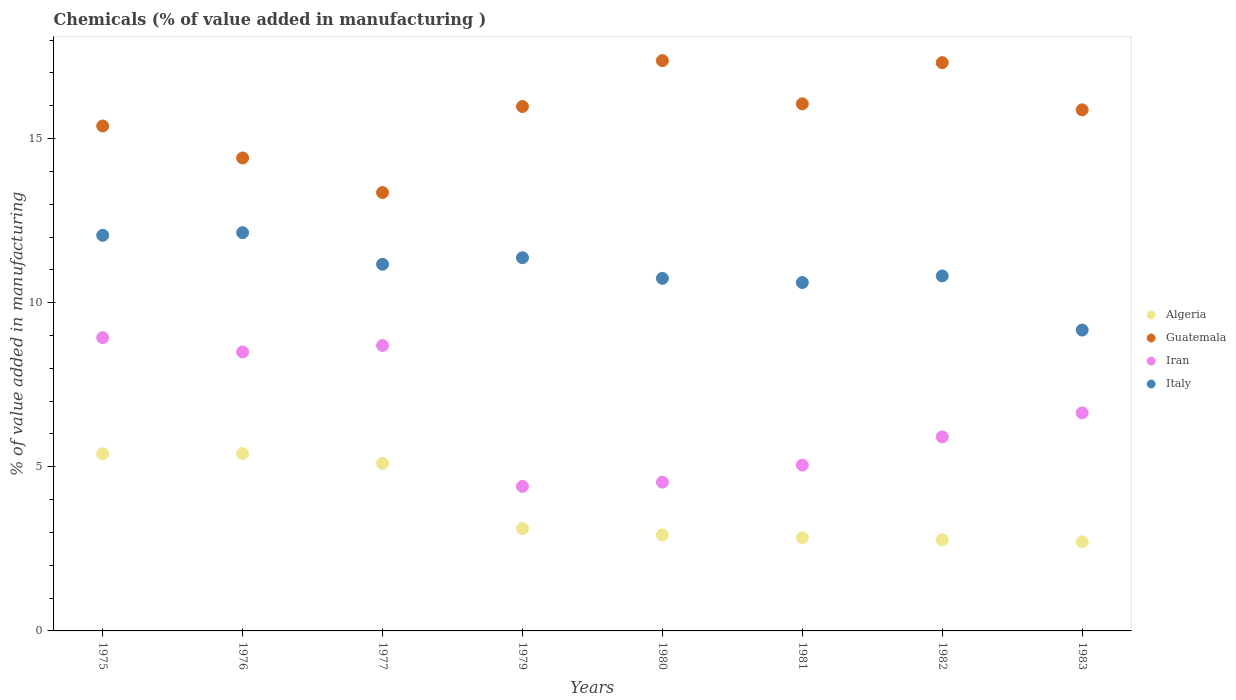How many different coloured dotlines are there?
Give a very brief answer. 4. What is the value added in manufacturing chemicals in Italy in 1976?
Ensure brevity in your answer.  12.13. Across all years, what is the maximum value added in manufacturing chemicals in Algeria?
Provide a succinct answer. 5.4. Across all years, what is the minimum value added in manufacturing chemicals in Guatemala?
Offer a very short reply. 13.36. In which year was the value added in manufacturing chemicals in Iran maximum?
Provide a short and direct response. 1975. In which year was the value added in manufacturing chemicals in Guatemala minimum?
Give a very brief answer. 1977. What is the total value added in manufacturing chemicals in Iran in the graph?
Give a very brief answer. 52.67. What is the difference between the value added in manufacturing chemicals in Iran in 1982 and that in 1983?
Your response must be concise. -0.73. What is the difference between the value added in manufacturing chemicals in Iran in 1975 and the value added in manufacturing chemicals in Guatemala in 1981?
Your answer should be compact. -7.12. What is the average value added in manufacturing chemicals in Iran per year?
Keep it short and to the point. 6.58. In the year 1981, what is the difference between the value added in manufacturing chemicals in Guatemala and value added in manufacturing chemicals in Italy?
Your answer should be compact. 5.44. In how many years, is the value added in manufacturing chemicals in Italy greater than 5 %?
Your response must be concise. 8. What is the ratio of the value added in manufacturing chemicals in Algeria in 1975 to that in 1982?
Provide a short and direct response. 1.94. Is the difference between the value added in manufacturing chemicals in Guatemala in 1977 and 1982 greater than the difference between the value added in manufacturing chemicals in Italy in 1977 and 1982?
Your answer should be very brief. No. What is the difference between the highest and the second highest value added in manufacturing chemicals in Iran?
Give a very brief answer. 0.24. What is the difference between the highest and the lowest value added in manufacturing chemicals in Algeria?
Keep it short and to the point. 2.69. In how many years, is the value added in manufacturing chemicals in Italy greater than the average value added in manufacturing chemicals in Italy taken over all years?
Your answer should be very brief. 4. Is it the case that in every year, the sum of the value added in manufacturing chemicals in Algeria and value added in manufacturing chemicals in Iran  is greater than the sum of value added in manufacturing chemicals in Guatemala and value added in manufacturing chemicals in Italy?
Offer a terse response. No. Does the value added in manufacturing chemicals in Algeria monotonically increase over the years?
Your answer should be very brief. No. Is the value added in manufacturing chemicals in Guatemala strictly less than the value added in manufacturing chemicals in Iran over the years?
Keep it short and to the point. No. How many dotlines are there?
Your response must be concise. 4. How many years are there in the graph?
Your response must be concise. 8. What is the difference between two consecutive major ticks on the Y-axis?
Your response must be concise. 5. Are the values on the major ticks of Y-axis written in scientific E-notation?
Your answer should be compact. No. Does the graph contain grids?
Keep it short and to the point. No. Where does the legend appear in the graph?
Give a very brief answer. Center right. How many legend labels are there?
Give a very brief answer. 4. How are the legend labels stacked?
Ensure brevity in your answer.  Vertical. What is the title of the graph?
Provide a short and direct response. Chemicals (% of value added in manufacturing ). Does "Micronesia" appear as one of the legend labels in the graph?
Offer a very short reply. No. What is the label or title of the Y-axis?
Your answer should be compact. % of value added in manufacturing. What is the % of value added in manufacturing in Algeria in 1975?
Keep it short and to the point. 5.4. What is the % of value added in manufacturing in Guatemala in 1975?
Your answer should be compact. 15.38. What is the % of value added in manufacturing of Iran in 1975?
Give a very brief answer. 8.94. What is the % of value added in manufacturing in Italy in 1975?
Offer a very short reply. 12.05. What is the % of value added in manufacturing in Algeria in 1976?
Make the answer very short. 5.4. What is the % of value added in manufacturing in Guatemala in 1976?
Keep it short and to the point. 14.41. What is the % of value added in manufacturing in Iran in 1976?
Provide a short and direct response. 8.5. What is the % of value added in manufacturing of Italy in 1976?
Your response must be concise. 12.13. What is the % of value added in manufacturing in Algeria in 1977?
Your response must be concise. 5.1. What is the % of value added in manufacturing of Guatemala in 1977?
Keep it short and to the point. 13.36. What is the % of value added in manufacturing in Iran in 1977?
Provide a succinct answer. 8.7. What is the % of value added in manufacturing of Italy in 1977?
Ensure brevity in your answer.  11.17. What is the % of value added in manufacturing of Algeria in 1979?
Offer a very short reply. 3.12. What is the % of value added in manufacturing of Guatemala in 1979?
Give a very brief answer. 15.98. What is the % of value added in manufacturing of Iran in 1979?
Offer a very short reply. 4.4. What is the % of value added in manufacturing in Italy in 1979?
Ensure brevity in your answer.  11.37. What is the % of value added in manufacturing in Algeria in 1980?
Provide a short and direct response. 2.93. What is the % of value added in manufacturing of Guatemala in 1980?
Your answer should be very brief. 17.37. What is the % of value added in manufacturing of Iran in 1980?
Make the answer very short. 4.53. What is the % of value added in manufacturing in Italy in 1980?
Offer a terse response. 10.74. What is the % of value added in manufacturing of Algeria in 1981?
Your response must be concise. 2.84. What is the % of value added in manufacturing in Guatemala in 1981?
Your answer should be compact. 16.06. What is the % of value added in manufacturing in Iran in 1981?
Give a very brief answer. 5.05. What is the % of value added in manufacturing in Italy in 1981?
Give a very brief answer. 10.61. What is the % of value added in manufacturing of Algeria in 1982?
Your response must be concise. 2.78. What is the % of value added in manufacturing in Guatemala in 1982?
Offer a terse response. 17.31. What is the % of value added in manufacturing of Iran in 1982?
Your response must be concise. 5.91. What is the % of value added in manufacturing of Italy in 1982?
Your answer should be compact. 10.82. What is the % of value added in manufacturing of Algeria in 1983?
Offer a very short reply. 2.71. What is the % of value added in manufacturing of Guatemala in 1983?
Provide a succinct answer. 15.88. What is the % of value added in manufacturing in Iran in 1983?
Provide a short and direct response. 6.64. What is the % of value added in manufacturing in Italy in 1983?
Provide a succinct answer. 9.17. Across all years, what is the maximum % of value added in manufacturing in Algeria?
Make the answer very short. 5.4. Across all years, what is the maximum % of value added in manufacturing of Guatemala?
Make the answer very short. 17.37. Across all years, what is the maximum % of value added in manufacturing of Iran?
Offer a terse response. 8.94. Across all years, what is the maximum % of value added in manufacturing in Italy?
Your response must be concise. 12.13. Across all years, what is the minimum % of value added in manufacturing of Algeria?
Provide a succinct answer. 2.71. Across all years, what is the minimum % of value added in manufacturing of Guatemala?
Your answer should be very brief. 13.36. Across all years, what is the minimum % of value added in manufacturing in Iran?
Provide a short and direct response. 4.4. Across all years, what is the minimum % of value added in manufacturing in Italy?
Make the answer very short. 9.17. What is the total % of value added in manufacturing in Algeria in the graph?
Give a very brief answer. 30.27. What is the total % of value added in manufacturing of Guatemala in the graph?
Make the answer very short. 125.74. What is the total % of value added in manufacturing of Iran in the graph?
Your answer should be compact. 52.67. What is the total % of value added in manufacturing of Italy in the graph?
Provide a succinct answer. 88.06. What is the difference between the % of value added in manufacturing of Algeria in 1975 and that in 1976?
Ensure brevity in your answer.  -0.01. What is the difference between the % of value added in manufacturing of Guatemala in 1975 and that in 1976?
Offer a very short reply. 0.97. What is the difference between the % of value added in manufacturing in Iran in 1975 and that in 1976?
Your answer should be very brief. 0.44. What is the difference between the % of value added in manufacturing of Italy in 1975 and that in 1976?
Provide a short and direct response. -0.08. What is the difference between the % of value added in manufacturing of Algeria in 1975 and that in 1977?
Your response must be concise. 0.29. What is the difference between the % of value added in manufacturing of Guatemala in 1975 and that in 1977?
Offer a very short reply. 2.03. What is the difference between the % of value added in manufacturing of Iran in 1975 and that in 1977?
Provide a succinct answer. 0.24. What is the difference between the % of value added in manufacturing of Italy in 1975 and that in 1977?
Your response must be concise. 0.88. What is the difference between the % of value added in manufacturing in Algeria in 1975 and that in 1979?
Provide a short and direct response. 2.28. What is the difference between the % of value added in manufacturing in Guatemala in 1975 and that in 1979?
Your answer should be compact. -0.59. What is the difference between the % of value added in manufacturing in Iran in 1975 and that in 1979?
Give a very brief answer. 4.53. What is the difference between the % of value added in manufacturing of Italy in 1975 and that in 1979?
Make the answer very short. 0.68. What is the difference between the % of value added in manufacturing of Algeria in 1975 and that in 1980?
Your answer should be very brief. 2.47. What is the difference between the % of value added in manufacturing of Guatemala in 1975 and that in 1980?
Offer a very short reply. -1.99. What is the difference between the % of value added in manufacturing of Iran in 1975 and that in 1980?
Keep it short and to the point. 4.4. What is the difference between the % of value added in manufacturing in Italy in 1975 and that in 1980?
Your answer should be very brief. 1.31. What is the difference between the % of value added in manufacturing in Algeria in 1975 and that in 1981?
Make the answer very short. 2.56. What is the difference between the % of value added in manufacturing of Guatemala in 1975 and that in 1981?
Provide a succinct answer. -0.68. What is the difference between the % of value added in manufacturing in Iran in 1975 and that in 1981?
Give a very brief answer. 3.88. What is the difference between the % of value added in manufacturing of Italy in 1975 and that in 1981?
Your answer should be compact. 1.44. What is the difference between the % of value added in manufacturing in Algeria in 1975 and that in 1982?
Keep it short and to the point. 2.62. What is the difference between the % of value added in manufacturing in Guatemala in 1975 and that in 1982?
Your response must be concise. -1.93. What is the difference between the % of value added in manufacturing in Iran in 1975 and that in 1982?
Provide a short and direct response. 3.03. What is the difference between the % of value added in manufacturing of Italy in 1975 and that in 1982?
Keep it short and to the point. 1.24. What is the difference between the % of value added in manufacturing in Algeria in 1975 and that in 1983?
Give a very brief answer. 2.68. What is the difference between the % of value added in manufacturing of Guatemala in 1975 and that in 1983?
Ensure brevity in your answer.  -0.49. What is the difference between the % of value added in manufacturing in Iran in 1975 and that in 1983?
Your answer should be compact. 2.29. What is the difference between the % of value added in manufacturing in Italy in 1975 and that in 1983?
Your answer should be very brief. 2.89. What is the difference between the % of value added in manufacturing of Algeria in 1976 and that in 1977?
Offer a very short reply. 0.3. What is the difference between the % of value added in manufacturing in Guatemala in 1976 and that in 1977?
Make the answer very short. 1.05. What is the difference between the % of value added in manufacturing of Iran in 1976 and that in 1977?
Provide a short and direct response. -0.2. What is the difference between the % of value added in manufacturing in Italy in 1976 and that in 1977?
Make the answer very short. 0.96. What is the difference between the % of value added in manufacturing of Algeria in 1976 and that in 1979?
Offer a terse response. 2.28. What is the difference between the % of value added in manufacturing of Guatemala in 1976 and that in 1979?
Offer a very short reply. -1.57. What is the difference between the % of value added in manufacturing of Iran in 1976 and that in 1979?
Provide a short and direct response. 4.1. What is the difference between the % of value added in manufacturing of Italy in 1976 and that in 1979?
Give a very brief answer. 0.76. What is the difference between the % of value added in manufacturing of Algeria in 1976 and that in 1980?
Make the answer very short. 2.48. What is the difference between the % of value added in manufacturing of Guatemala in 1976 and that in 1980?
Provide a succinct answer. -2.97. What is the difference between the % of value added in manufacturing of Iran in 1976 and that in 1980?
Your answer should be very brief. 3.97. What is the difference between the % of value added in manufacturing in Italy in 1976 and that in 1980?
Make the answer very short. 1.39. What is the difference between the % of value added in manufacturing of Algeria in 1976 and that in 1981?
Your answer should be very brief. 2.56. What is the difference between the % of value added in manufacturing in Guatemala in 1976 and that in 1981?
Make the answer very short. -1.65. What is the difference between the % of value added in manufacturing of Iran in 1976 and that in 1981?
Give a very brief answer. 3.45. What is the difference between the % of value added in manufacturing of Italy in 1976 and that in 1981?
Provide a succinct answer. 1.52. What is the difference between the % of value added in manufacturing in Algeria in 1976 and that in 1982?
Make the answer very short. 2.62. What is the difference between the % of value added in manufacturing in Guatemala in 1976 and that in 1982?
Your answer should be compact. -2.9. What is the difference between the % of value added in manufacturing in Iran in 1976 and that in 1982?
Keep it short and to the point. 2.59. What is the difference between the % of value added in manufacturing of Italy in 1976 and that in 1982?
Your answer should be very brief. 1.32. What is the difference between the % of value added in manufacturing of Algeria in 1976 and that in 1983?
Your response must be concise. 2.69. What is the difference between the % of value added in manufacturing of Guatemala in 1976 and that in 1983?
Make the answer very short. -1.47. What is the difference between the % of value added in manufacturing in Iran in 1976 and that in 1983?
Provide a succinct answer. 1.86. What is the difference between the % of value added in manufacturing of Italy in 1976 and that in 1983?
Provide a short and direct response. 2.97. What is the difference between the % of value added in manufacturing of Algeria in 1977 and that in 1979?
Provide a short and direct response. 1.98. What is the difference between the % of value added in manufacturing in Guatemala in 1977 and that in 1979?
Your answer should be compact. -2.62. What is the difference between the % of value added in manufacturing in Iran in 1977 and that in 1979?
Give a very brief answer. 4.29. What is the difference between the % of value added in manufacturing in Italy in 1977 and that in 1979?
Your answer should be compact. -0.2. What is the difference between the % of value added in manufacturing in Algeria in 1977 and that in 1980?
Offer a very short reply. 2.18. What is the difference between the % of value added in manufacturing in Guatemala in 1977 and that in 1980?
Your response must be concise. -4.02. What is the difference between the % of value added in manufacturing of Iran in 1977 and that in 1980?
Your answer should be very brief. 4.16. What is the difference between the % of value added in manufacturing in Italy in 1977 and that in 1980?
Make the answer very short. 0.43. What is the difference between the % of value added in manufacturing in Algeria in 1977 and that in 1981?
Offer a terse response. 2.26. What is the difference between the % of value added in manufacturing in Guatemala in 1977 and that in 1981?
Keep it short and to the point. -2.7. What is the difference between the % of value added in manufacturing in Iran in 1977 and that in 1981?
Provide a short and direct response. 3.64. What is the difference between the % of value added in manufacturing of Italy in 1977 and that in 1981?
Your answer should be compact. 0.56. What is the difference between the % of value added in manufacturing in Algeria in 1977 and that in 1982?
Your answer should be compact. 2.32. What is the difference between the % of value added in manufacturing of Guatemala in 1977 and that in 1982?
Offer a very short reply. -3.96. What is the difference between the % of value added in manufacturing of Iran in 1977 and that in 1982?
Provide a succinct answer. 2.78. What is the difference between the % of value added in manufacturing of Italy in 1977 and that in 1982?
Offer a terse response. 0.36. What is the difference between the % of value added in manufacturing in Algeria in 1977 and that in 1983?
Make the answer very short. 2.39. What is the difference between the % of value added in manufacturing of Guatemala in 1977 and that in 1983?
Make the answer very short. -2.52. What is the difference between the % of value added in manufacturing of Iran in 1977 and that in 1983?
Your answer should be compact. 2.05. What is the difference between the % of value added in manufacturing in Italy in 1977 and that in 1983?
Offer a terse response. 2. What is the difference between the % of value added in manufacturing in Algeria in 1979 and that in 1980?
Offer a terse response. 0.19. What is the difference between the % of value added in manufacturing in Guatemala in 1979 and that in 1980?
Offer a terse response. -1.4. What is the difference between the % of value added in manufacturing in Iran in 1979 and that in 1980?
Provide a short and direct response. -0.13. What is the difference between the % of value added in manufacturing of Italy in 1979 and that in 1980?
Make the answer very short. 0.63. What is the difference between the % of value added in manufacturing of Algeria in 1979 and that in 1981?
Provide a short and direct response. 0.28. What is the difference between the % of value added in manufacturing in Guatemala in 1979 and that in 1981?
Offer a very short reply. -0.08. What is the difference between the % of value added in manufacturing in Iran in 1979 and that in 1981?
Make the answer very short. -0.65. What is the difference between the % of value added in manufacturing of Italy in 1979 and that in 1981?
Ensure brevity in your answer.  0.76. What is the difference between the % of value added in manufacturing of Algeria in 1979 and that in 1982?
Keep it short and to the point. 0.34. What is the difference between the % of value added in manufacturing in Guatemala in 1979 and that in 1982?
Offer a very short reply. -1.34. What is the difference between the % of value added in manufacturing in Iran in 1979 and that in 1982?
Your response must be concise. -1.51. What is the difference between the % of value added in manufacturing of Italy in 1979 and that in 1982?
Your answer should be compact. 0.55. What is the difference between the % of value added in manufacturing in Algeria in 1979 and that in 1983?
Keep it short and to the point. 0.41. What is the difference between the % of value added in manufacturing in Guatemala in 1979 and that in 1983?
Provide a short and direct response. 0.1. What is the difference between the % of value added in manufacturing of Iran in 1979 and that in 1983?
Keep it short and to the point. -2.24. What is the difference between the % of value added in manufacturing in Italy in 1979 and that in 1983?
Keep it short and to the point. 2.2. What is the difference between the % of value added in manufacturing in Algeria in 1980 and that in 1981?
Provide a succinct answer. 0.09. What is the difference between the % of value added in manufacturing in Guatemala in 1980 and that in 1981?
Provide a short and direct response. 1.32. What is the difference between the % of value added in manufacturing of Iran in 1980 and that in 1981?
Ensure brevity in your answer.  -0.52. What is the difference between the % of value added in manufacturing in Italy in 1980 and that in 1981?
Your response must be concise. 0.13. What is the difference between the % of value added in manufacturing of Algeria in 1980 and that in 1982?
Give a very brief answer. 0.15. What is the difference between the % of value added in manufacturing in Guatemala in 1980 and that in 1982?
Your answer should be very brief. 0.06. What is the difference between the % of value added in manufacturing of Iran in 1980 and that in 1982?
Make the answer very short. -1.38. What is the difference between the % of value added in manufacturing of Italy in 1980 and that in 1982?
Offer a terse response. -0.07. What is the difference between the % of value added in manufacturing in Algeria in 1980 and that in 1983?
Offer a very short reply. 0.21. What is the difference between the % of value added in manufacturing of Guatemala in 1980 and that in 1983?
Your answer should be compact. 1.5. What is the difference between the % of value added in manufacturing in Iran in 1980 and that in 1983?
Your answer should be very brief. -2.11. What is the difference between the % of value added in manufacturing in Italy in 1980 and that in 1983?
Give a very brief answer. 1.57. What is the difference between the % of value added in manufacturing of Algeria in 1981 and that in 1982?
Provide a succinct answer. 0.06. What is the difference between the % of value added in manufacturing of Guatemala in 1981 and that in 1982?
Offer a terse response. -1.25. What is the difference between the % of value added in manufacturing of Iran in 1981 and that in 1982?
Keep it short and to the point. -0.86. What is the difference between the % of value added in manufacturing in Italy in 1981 and that in 1982?
Offer a very short reply. -0.2. What is the difference between the % of value added in manufacturing of Algeria in 1981 and that in 1983?
Give a very brief answer. 0.13. What is the difference between the % of value added in manufacturing of Guatemala in 1981 and that in 1983?
Give a very brief answer. 0.18. What is the difference between the % of value added in manufacturing of Iran in 1981 and that in 1983?
Provide a short and direct response. -1.59. What is the difference between the % of value added in manufacturing in Italy in 1981 and that in 1983?
Keep it short and to the point. 1.45. What is the difference between the % of value added in manufacturing of Algeria in 1982 and that in 1983?
Provide a short and direct response. 0.07. What is the difference between the % of value added in manufacturing in Guatemala in 1982 and that in 1983?
Keep it short and to the point. 1.44. What is the difference between the % of value added in manufacturing in Iran in 1982 and that in 1983?
Offer a terse response. -0.73. What is the difference between the % of value added in manufacturing of Italy in 1982 and that in 1983?
Your response must be concise. 1.65. What is the difference between the % of value added in manufacturing of Algeria in 1975 and the % of value added in manufacturing of Guatemala in 1976?
Offer a terse response. -9.01. What is the difference between the % of value added in manufacturing of Algeria in 1975 and the % of value added in manufacturing of Iran in 1976?
Provide a succinct answer. -3.1. What is the difference between the % of value added in manufacturing in Algeria in 1975 and the % of value added in manufacturing in Italy in 1976?
Keep it short and to the point. -6.74. What is the difference between the % of value added in manufacturing in Guatemala in 1975 and the % of value added in manufacturing in Iran in 1976?
Your answer should be very brief. 6.88. What is the difference between the % of value added in manufacturing of Guatemala in 1975 and the % of value added in manufacturing of Italy in 1976?
Provide a short and direct response. 3.25. What is the difference between the % of value added in manufacturing of Iran in 1975 and the % of value added in manufacturing of Italy in 1976?
Your answer should be compact. -3.2. What is the difference between the % of value added in manufacturing of Algeria in 1975 and the % of value added in manufacturing of Guatemala in 1977?
Offer a terse response. -7.96. What is the difference between the % of value added in manufacturing in Algeria in 1975 and the % of value added in manufacturing in Iran in 1977?
Give a very brief answer. -3.3. What is the difference between the % of value added in manufacturing of Algeria in 1975 and the % of value added in manufacturing of Italy in 1977?
Your answer should be very brief. -5.78. What is the difference between the % of value added in manufacturing in Guatemala in 1975 and the % of value added in manufacturing in Iran in 1977?
Provide a succinct answer. 6.69. What is the difference between the % of value added in manufacturing of Guatemala in 1975 and the % of value added in manufacturing of Italy in 1977?
Provide a short and direct response. 4.21. What is the difference between the % of value added in manufacturing in Iran in 1975 and the % of value added in manufacturing in Italy in 1977?
Your response must be concise. -2.23. What is the difference between the % of value added in manufacturing of Algeria in 1975 and the % of value added in manufacturing of Guatemala in 1979?
Give a very brief answer. -10.58. What is the difference between the % of value added in manufacturing of Algeria in 1975 and the % of value added in manufacturing of Italy in 1979?
Provide a succinct answer. -5.97. What is the difference between the % of value added in manufacturing of Guatemala in 1975 and the % of value added in manufacturing of Iran in 1979?
Give a very brief answer. 10.98. What is the difference between the % of value added in manufacturing of Guatemala in 1975 and the % of value added in manufacturing of Italy in 1979?
Your response must be concise. 4.01. What is the difference between the % of value added in manufacturing of Iran in 1975 and the % of value added in manufacturing of Italy in 1979?
Make the answer very short. -2.43. What is the difference between the % of value added in manufacturing of Algeria in 1975 and the % of value added in manufacturing of Guatemala in 1980?
Give a very brief answer. -11.98. What is the difference between the % of value added in manufacturing in Algeria in 1975 and the % of value added in manufacturing in Iran in 1980?
Give a very brief answer. 0.86. What is the difference between the % of value added in manufacturing in Algeria in 1975 and the % of value added in manufacturing in Italy in 1980?
Make the answer very short. -5.35. What is the difference between the % of value added in manufacturing of Guatemala in 1975 and the % of value added in manufacturing of Iran in 1980?
Offer a very short reply. 10.85. What is the difference between the % of value added in manufacturing in Guatemala in 1975 and the % of value added in manufacturing in Italy in 1980?
Make the answer very short. 4.64. What is the difference between the % of value added in manufacturing of Iran in 1975 and the % of value added in manufacturing of Italy in 1980?
Ensure brevity in your answer.  -1.8. What is the difference between the % of value added in manufacturing of Algeria in 1975 and the % of value added in manufacturing of Guatemala in 1981?
Your answer should be compact. -10.66. What is the difference between the % of value added in manufacturing in Algeria in 1975 and the % of value added in manufacturing in Iran in 1981?
Keep it short and to the point. 0.34. What is the difference between the % of value added in manufacturing of Algeria in 1975 and the % of value added in manufacturing of Italy in 1981?
Your response must be concise. -5.22. What is the difference between the % of value added in manufacturing in Guatemala in 1975 and the % of value added in manufacturing in Iran in 1981?
Your response must be concise. 10.33. What is the difference between the % of value added in manufacturing in Guatemala in 1975 and the % of value added in manufacturing in Italy in 1981?
Your answer should be very brief. 4.77. What is the difference between the % of value added in manufacturing in Iran in 1975 and the % of value added in manufacturing in Italy in 1981?
Your response must be concise. -1.68. What is the difference between the % of value added in manufacturing of Algeria in 1975 and the % of value added in manufacturing of Guatemala in 1982?
Your response must be concise. -11.92. What is the difference between the % of value added in manufacturing of Algeria in 1975 and the % of value added in manufacturing of Iran in 1982?
Ensure brevity in your answer.  -0.52. What is the difference between the % of value added in manufacturing in Algeria in 1975 and the % of value added in manufacturing in Italy in 1982?
Give a very brief answer. -5.42. What is the difference between the % of value added in manufacturing in Guatemala in 1975 and the % of value added in manufacturing in Iran in 1982?
Your response must be concise. 9.47. What is the difference between the % of value added in manufacturing in Guatemala in 1975 and the % of value added in manufacturing in Italy in 1982?
Make the answer very short. 4.57. What is the difference between the % of value added in manufacturing of Iran in 1975 and the % of value added in manufacturing of Italy in 1982?
Keep it short and to the point. -1.88. What is the difference between the % of value added in manufacturing of Algeria in 1975 and the % of value added in manufacturing of Guatemala in 1983?
Give a very brief answer. -10.48. What is the difference between the % of value added in manufacturing of Algeria in 1975 and the % of value added in manufacturing of Iran in 1983?
Provide a succinct answer. -1.25. What is the difference between the % of value added in manufacturing in Algeria in 1975 and the % of value added in manufacturing in Italy in 1983?
Keep it short and to the point. -3.77. What is the difference between the % of value added in manufacturing of Guatemala in 1975 and the % of value added in manufacturing of Iran in 1983?
Your answer should be very brief. 8.74. What is the difference between the % of value added in manufacturing of Guatemala in 1975 and the % of value added in manufacturing of Italy in 1983?
Your answer should be compact. 6.22. What is the difference between the % of value added in manufacturing of Iran in 1975 and the % of value added in manufacturing of Italy in 1983?
Provide a succinct answer. -0.23. What is the difference between the % of value added in manufacturing in Algeria in 1976 and the % of value added in manufacturing in Guatemala in 1977?
Provide a short and direct response. -7.95. What is the difference between the % of value added in manufacturing of Algeria in 1976 and the % of value added in manufacturing of Iran in 1977?
Your answer should be compact. -3.29. What is the difference between the % of value added in manufacturing of Algeria in 1976 and the % of value added in manufacturing of Italy in 1977?
Give a very brief answer. -5.77. What is the difference between the % of value added in manufacturing of Guatemala in 1976 and the % of value added in manufacturing of Iran in 1977?
Your answer should be compact. 5.71. What is the difference between the % of value added in manufacturing in Guatemala in 1976 and the % of value added in manufacturing in Italy in 1977?
Ensure brevity in your answer.  3.24. What is the difference between the % of value added in manufacturing of Iran in 1976 and the % of value added in manufacturing of Italy in 1977?
Ensure brevity in your answer.  -2.67. What is the difference between the % of value added in manufacturing in Algeria in 1976 and the % of value added in manufacturing in Guatemala in 1979?
Give a very brief answer. -10.57. What is the difference between the % of value added in manufacturing in Algeria in 1976 and the % of value added in manufacturing in Italy in 1979?
Provide a succinct answer. -5.97. What is the difference between the % of value added in manufacturing in Guatemala in 1976 and the % of value added in manufacturing in Iran in 1979?
Offer a very short reply. 10.01. What is the difference between the % of value added in manufacturing of Guatemala in 1976 and the % of value added in manufacturing of Italy in 1979?
Keep it short and to the point. 3.04. What is the difference between the % of value added in manufacturing of Iran in 1976 and the % of value added in manufacturing of Italy in 1979?
Offer a very short reply. -2.87. What is the difference between the % of value added in manufacturing of Algeria in 1976 and the % of value added in manufacturing of Guatemala in 1980?
Keep it short and to the point. -11.97. What is the difference between the % of value added in manufacturing in Algeria in 1976 and the % of value added in manufacturing in Iran in 1980?
Offer a terse response. 0.87. What is the difference between the % of value added in manufacturing in Algeria in 1976 and the % of value added in manufacturing in Italy in 1980?
Provide a succinct answer. -5.34. What is the difference between the % of value added in manufacturing in Guatemala in 1976 and the % of value added in manufacturing in Iran in 1980?
Provide a succinct answer. 9.88. What is the difference between the % of value added in manufacturing of Guatemala in 1976 and the % of value added in manufacturing of Italy in 1980?
Provide a succinct answer. 3.67. What is the difference between the % of value added in manufacturing in Iran in 1976 and the % of value added in manufacturing in Italy in 1980?
Offer a terse response. -2.24. What is the difference between the % of value added in manufacturing in Algeria in 1976 and the % of value added in manufacturing in Guatemala in 1981?
Make the answer very short. -10.66. What is the difference between the % of value added in manufacturing in Algeria in 1976 and the % of value added in manufacturing in Iran in 1981?
Offer a terse response. 0.35. What is the difference between the % of value added in manufacturing of Algeria in 1976 and the % of value added in manufacturing of Italy in 1981?
Offer a very short reply. -5.21. What is the difference between the % of value added in manufacturing in Guatemala in 1976 and the % of value added in manufacturing in Iran in 1981?
Your answer should be compact. 9.36. What is the difference between the % of value added in manufacturing in Guatemala in 1976 and the % of value added in manufacturing in Italy in 1981?
Make the answer very short. 3.79. What is the difference between the % of value added in manufacturing in Iran in 1976 and the % of value added in manufacturing in Italy in 1981?
Make the answer very short. -2.12. What is the difference between the % of value added in manufacturing of Algeria in 1976 and the % of value added in manufacturing of Guatemala in 1982?
Provide a succinct answer. -11.91. What is the difference between the % of value added in manufacturing in Algeria in 1976 and the % of value added in manufacturing in Iran in 1982?
Make the answer very short. -0.51. What is the difference between the % of value added in manufacturing of Algeria in 1976 and the % of value added in manufacturing of Italy in 1982?
Ensure brevity in your answer.  -5.41. What is the difference between the % of value added in manufacturing in Guatemala in 1976 and the % of value added in manufacturing in Iran in 1982?
Your answer should be compact. 8.5. What is the difference between the % of value added in manufacturing of Guatemala in 1976 and the % of value added in manufacturing of Italy in 1982?
Your answer should be very brief. 3.59. What is the difference between the % of value added in manufacturing of Iran in 1976 and the % of value added in manufacturing of Italy in 1982?
Your answer should be very brief. -2.32. What is the difference between the % of value added in manufacturing of Algeria in 1976 and the % of value added in manufacturing of Guatemala in 1983?
Offer a terse response. -10.47. What is the difference between the % of value added in manufacturing in Algeria in 1976 and the % of value added in manufacturing in Iran in 1983?
Provide a short and direct response. -1.24. What is the difference between the % of value added in manufacturing in Algeria in 1976 and the % of value added in manufacturing in Italy in 1983?
Provide a succinct answer. -3.76. What is the difference between the % of value added in manufacturing of Guatemala in 1976 and the % of value added in manufacturing of Iran in 1983?
Provide a short and direct response. 7.77. What is the difference between the % of value added in manufacturing of Guatemala in 1976 and the % of value added in manufacturing of Italy in 1983?
Provide a succinct answer. 5.24. What is the difference between the % of value added in manufacturing of Iran in 1976 and the % of value added in manufacturing of Italy in 1983?
Provide a succinct answer. -0.67. What is the difference between the % of value added in manufacturing of Algeria in 1977 and the % of value added in manufacturing of Guatemala in 1979?
Offer a very short reply. -10.87. What is the difference between the % of value added in manufacturing in Algeria in 1977 and the % of value added in manufacturing in Iran in 1979?
Provide a succinct answer. 0.7. What is the difference between the % of value added in manufacturing in Algeria in 1977 and the % of value added in manufacturing in Italy in 1979?
Your response must be concise. -6.27. What is the difference between the % of value added in manufacturing in Guatemala in 1977 and the % of value added in manufacturing in Iran in 1979?
Provide a short and direct response. 8.95. What is the difference between the % of value added in manufacturing of Guatemala in 1977 and the % of value added in manufacturing of Italy in 1979?
Provide a succinct answer. 1.99. What is the difference between the % of value added in manufacturing in Iran in 1977 and the % of value added in manufacturing in Italy in 1979?
Make the answer very short. -2.67. What is the difference between the % of value added in manufacturing of Algeria in 1977 and the % of value added in manufacturing of Guatemala in 1980?
Make the answer very short. -12.27. What is the difference between the % of value added in manufacturing in Algeria in 1977 and the % of value added in manufacturing in Iran in 1980?
Offer a very short reply. 0.57. What is the difference between the % of value added in manufacturing of Algeria in 1977 and the % of value added in manufacturing of Italy in 1980?
Provide a short and direct response. -5.64. What is the difference between the % of value added in manufacturing in Guatemala in 1977 and the % of value added in manufacturing in Iran in 1980?
Ensure brevity in your answer.  8.82. What is the difference between the % of value added in manufacturing in Guatemala in 1977 and the % of value added in manufacturing in Italy in 1980?
Give a very brief answer. 2.61. What is the difference between the % of value added in manufacturing of Iran in 1977 and the % of value added in manufacturing of Italy in 1980?
Provide a short and direct response. -2.05. What is the difference between the % of value added in manufacturing of Algeria in 1977 and the % of value added in manufacturing of Guatemala in 1981?
Provide a short and direct response. -10.96. What is the difference between the % of value added in manufacturing in Algeria in 1977 and the % of value added in manufacturing in Iran in 1981?
Give a very brief answer. 0.05. What is the difference between the % of value added in manufacturing of Algeria in 1977 and the % of value added in manufacturing of Italy in 1981?
Provide a succinct answer. -5.51. What is the difference between the % of value added in manufacturing in Guatemala in 1977 and the % of value added in manufacturing in Iran in 1981?
Provide a succinct answer. 8.3. What is the difference between the % of value added in manufacturing in Guatemala in 1977 and the % of value added in manufacturing in Italy in 1981?
Provide a short and direct response. 2.74. What is the difference between the % of value added in manufacturing in Iran in 1977 and the % of value added in manufacturing in Italy in 1981?
Provide a succinct answer. -1.92. What is the difference between the % of value added in manufacturing in Algeria in 1977 and the % of value added in manufacturing in Guatemala in 1982?
Your answer should be very brief. -12.21. What is the difference between the % of value added in manufacturing in Algeria in 1977 and the % of value added in manufacturing in Iran in 1982?
Your answer should be compact. -0.81. What is the difference between the % of value added in manufacturing of Algeria in 1977 and the % of value added in manufacturing of Italy in 1982?
Ensure brevity in your answer.  -5.71. What is the difference between the % of value added in manufacturing in Guatemala in 1977 and the % of value added in manufacturing in Iran in 1982?
Your response must be concise. 7.44. What is the difference between the % of value added in manufacturing in Guatemala in 1977 and the % of value added in manufacturing in Italy in 1982?
Provide a succinct answer. 2.54. What is the difference between the % of value added in manufacturing in Iran in 1977 and the % of value added in manufacturing in Italy in 1982?
Your answer should be very brief. -2.12. What is the difference between the % of value added in manufacturing in Algeria in 1977 and the % of value added in manufacturing in Guatemala in 1983?
Give a very brief answer. -10.77. What is the difference between the % of value added in manufacturing of Algeria in 1977 and the % of value added in manufacturing of Iran in 1983?
Provide a short and direct response. -1.54. What is the difference between the % of value added in manufacturing in Algeria in 1977 and the % of value added in manufacturing in Italy in 1983?
Provide a succinct answer. -4.06. What is the difference between the % of value added in manufacturing of Guatemala in 1977 and the % of value added in manufacturing of Iran in 1983?
Offer a terse response. 6.71. What is the difference between the % of value added in manufacturing in Guatemala in 1977 and the % of value added in manufacturing in Italy in 1983?
Offer a terse response. 4.19. What is the difference between the % of value added in manufacturing in Iran in 1977 and the % of value added in manufacturing in Italy in 1983?
Your response must be concise. -0.47. What is the difference between the % of value added in manufacturing of Algeria in 1979 and the % of value added in manufacturing of Guatemala in 1980?
Give a very brief answer. -14.26. What is the difference between the % of value added in manufacturing of Algeria in 1979 and the % of value added in manufacturing of Iran in 1980?
Your response must be concise. -1.41. What is the difference between the % of value added in manufacturing of Algeria in 1979 and the % of value added in manufacturing of Italy in 1980?
Your response must be concise. -7.62. What is the difference between the % of value added in manufacturing of Guatemala in 1979 and the % of value added in manufacturing of Iran in 1980?
Provide a short and direct response. 11.44. What is the difference between the % of value added in manufacturing in Guatemala in 1979 and the % of value added in manufacturing in Italy in 1980?
Make the answer very short. 5.24. What is the difference between the % of value added in manufacturing of Iran in 1979 and the % of value added in manufacturing of Italy in 1980?
Offer a terse response. -6.34. What is the difference between the % of value added in manufacturing in Algeria in 1979 and the % of value added in manufacturing in Guatemala in 1981?
Give a very brief answer. -12.94. What is the difference between the % of value added in manufacturing in Algeria in 1979 and the % of value added in manufacturing in Iran in 1981?
Offer a very short reply. -1.93. What is the difference between the % of value added in manufacturing of Algeria in 1979 and the % of value added in manufacturing of Italy in 1981?
Your response must be concise. -7.5. What is the difference between the % of value added in manufacturing in Guatemala in 1979 and the % of value added in manufacturing in Iran in 1981?
Offer a terse response. 10.92. What is the difference between the % of value added in manufacturing in Guatemala in 1979 and the % of value added in manufacturing in Italy in 1981?
Offer a terse response. 5.36. What is the difference between the % of value added in manufacturing in Iran in 1979 and the % of value added in manufacturing in Italy in 1981?
Provide a succinct answer. -6.21. What is the difference between the % of value added in manufacturing of Algeria in 1979 and the % of value added in manufacturing of Guatemala in 1982?
Provide a short and direct response. -14.19. What is the difference between the % of value added in manufacturing of Algeria in 1979 and the % of value added in manufacturing of Iran in 1982?
Offer a terse response. -2.79. What is the difference between the % of value added in manufacturing in Algeria in 1979 and the % of value added in manufacturing in Italy in 1982?
Your response must be concise. -7.7. What is the difference between the % of value added in manufacturing of Guatemala in 1979 and the % of value added in manufacturing of Iran in 1982?
Provide a succinct answer. 10.07. What is the difference between the % of value added in manufacturing of Guatemala in 1979 and the % of value added in manufacturing of Italy in 1982?
Your response must be concise. 5.16. What is the difference between the % of value added in manufacturing of Iran in 1979 and the % of value added in manufacturing of Italy in 1982?
Keep it short and to the point. -6.41. What is the difference between the % of value added in manufacturing of Algeria in 1979 and the % of value added in manufacturing of Guatemala in 1983?
Offer a very short reply. -12.76. What is the difference between the % of value added in manufacturing in Algeria in 1979 and the % of value added in manufacturing in Iran in 1983?
Ensure brevity in your answer.  -3.52. What is the difference between the % of value added in manufacturing in Algeria in 1979 and the % of value added in manufacturing in Italy in 1983?
Make the answer very short. -6.05. What is the difference between the % of value added in manufacturing in Guatemala in 1979 and the % of value added in manufacturing in Iran in 1983?
Your response must be concise. 9.33. What is the difference between the % of value added in manufacturing of Guatemala in 1979 and the % of value added in manufacturing of Italy in 1983?
Keep it short and to the point. 6.81. What is the difference between the % of value added in manufacturing of Iran in 1979 and the % of value added in manufacturing of Italy in 1983?
Provide a succinct answer. -4.76. What is the difference between the % of value added in manufacturing of Algeria in 1980 and the % of value added in manufacturing of Guatemala in 1981?
Offer a terse response. -13.13. What is the difference between the % of value added in manufacturing of Algeria in 1980 and the % of value added in manufacturing of Iran in 1981?
Provide a succinct answer. -2.13. What is the difference between the % of value added in manufacturing of Algeria in 1980 and the % of value added in manufacturing of Italy in 1981?
Keep it short and to the point. -7.69. What is the difference between the % of value added in manufacturing of Guatemala in 1980 and the % of value added in manufacturing of Iran in 1981?
Keep it short and to the point. 12.32. What is the difference between the % of value added in manufacturing of Guatemala in 1980 and the % of value added in manufacturing of Italy in 1981?
Your answer should be very brief. 6.76. What is the difference between the % of value added in manufacturing in Iran in 1980 and the % of value added in manufacturing in Italy in 1981?
Provide a succinct answer. -6.08. What is the difference between the % of value added in manufacturing in Algeria in 1980 and the % of value added in manufacturing in Guatemala in 1982?
Offer a terse response. -14.39. What is the difference between the % of value added in manufacturing of Algeria in 1980 and the % of value added in manufacturing of Iran in 1982?
Your answer should be very brief. -2.99. What is the difference between the % of value added in manufacturing of Algeria in 1980 and the % of value added in manufacturing of Italy in 1982?
Ensure brevity in your answer.  -7.89. What is the difference between the % of value added in manufacturing in Guatemala in 1980 and the % of value added in manufacturing in Iran in 1982?
Provide a succinct answer. 11.46. What is the difference between the % of value added in manufacturing of Guatemala in 1980 and the % of value added in manufacturing of Italy in 1982?
Offer a terse response. 6.56. What is the difference between the % of value added in manufacturing of Iran in 1980 and the % of value added in manufacturing of Italy in 1982?
Provide a short and direct response. -6.28. What is the difference between the % of value added in manufacturing of Algeria in 1980 and the % of value added in manufacturing of Guatemala in 1983?
Ensure brevity in your answer.  -12.95. What is the difference between the % of value added in manufacturing of Algeria in 1980 and the % of value added in manufacturing of Iran in 1983?
Your answer should be compact. -3.72. What is the difference between the % of value added in manufacturing of Algeria in 1980 and the % of value added in manufacturing of Italy in 1983?
Offer a very short reply. -6.24. What is the difference between the % of value added in manufacturing in Guatemala in 1980 and the % of value added in manufacturing in Iran in 1983?
Give a very brief answer. 10.73. What is the difference between the % of value added in manufacturing in Guatemala in 1980 and the % of value added in manufacturing in Italy in 1983?
Offer a very short reply. 8.21. What is the difference between the % of value added in manufacturing in Iran in 1980 and the % of value added in manufacturing in Italy in 1983?
Keep it short and to the point. -4.63. What is the difference between the % of value added in manufacturing in Algeria in 1981 and the % of value added in manufacturing in Guatemala in 1982?
Offer a terse response. -14.47. What is the difference between the % of value added in manufacturing in Algeria in 1981 and the % of value added in manufacturing in Iran in 1982?
Give a very brief answer. -3.07. What is the difference between the % of value added in manufacturing of Algeria in 1981 and the % of value added in manufacturing of Italy in 1982?
Give a very brief answer. -7.98. What is the difference between the % of value added in manufacturing in Guatemala in 1981 and the % of value added in manufacturing in Iran in 1982?
Ensure brevity in your answer.  10.15. What is the difference between the % of value added in manufacturing in Guatemala in 1981 and the % of value added in manufacturing in Italy in 1982?
Your response must be concise. 5.24. What is the difference between the % of value added in manufacturing in Iran in 1981 and the % of value added in manufacturing in Italy in 1982?
Make the answer very short. -5.76. What is the difference between the % of value added in manufacturing of Algeria in 1981 and the % of value added in manufacturing of Guatemala in 1983?
Provide a succinct answer. -13.04. What is the difference between the % of value added in manufacturing in Algeria in 1981 and the % of value added in manufacturing in Iran in 1983?
Your answer should be compact. -3.8. What is the difference between the % of value added in manufacturing in Algeria in 1981 and the % of value added in manufacturing in Italy in 1983?
Your answer should be very brief. -6.33. What is the difference between the % of value added in manufacturing in Guatemala in 1981 and the % of value added in manufacturing in Iran in 1983?
Your response must be concise. 9.41. What is the difference between the % of value added in manufacturing of Guatemala in 1981 and the % of value added in manufacturing of Italy in 1983?
Give a very brief answer. 6.89. What is the difference between the % of value added in manufacturing of Iran in 1981 and the % of value added in manufacturing of Italy in 1983?
Your answer should be compact. -4.11. What is the difference between the % of value added in manufacturing in Algeria in 1982 and the % of value added in manufacturing in Guatemala in 1983?
Offer a terse response. -13.1. What is the difference between the % of value added in manufacturing of Algeria in 1982 and the % of value added in manufacturing of Iran in 1983?
Provide a short and direct response. -3.86. What is the difference between the % of value added in manufacturing in Algeria in 1982 and the % of value added in manufacturing in Italy in 1983?
Your answer should be compact. -6.39. What is the difference between the % of value added in manufacturing in Guatemala in 1982 and the % of value added in manufacturing in Iran in 1983?
Your answer should be compact. 10.67. What is the difference between the % of value added in manufacturing of Guatemala in 1982 and the % of value added in manufacturing of Italy in 1983?
Your response must be concise. 8.15. What is the difference between the % of value added in manufacturing in Iran in 1982 and the % of value added in manufacturing in Italy in 1983?
Provide a succinct answer. -3.26. What is the average % of value added in manufacturing in Algeria per year?
Keep it short and to the point. 3.78. What is the average % of value added in manufacturing of Guatemala per year?
Give a very brief answer. 15.72. What is the average % of value added in manufacturing of Iran per year?
Offer a very short reply. 6.58. What is the average % of value added in manufacturing of Italy per year?
Your response must be concise. 11.01. In the year 1975, what is the difference between the % of value added in manufacturing in Algeria and % of value added in manufacturing in Guatemala?
Give a very brief answer. -9.99. In the year 1975, what is the difference between the % of value added in manufacturing of Algeria and % of value added in manufacturing of Iran?
Ensure brevity in your answer.  -3.54. In the year 1975, what is the difference between the % of value added in manufacturing of Algeria and % of value added in manufacturing of Italy?
Ensure brevity in your answer.  -6.66. In the year 1975, what is the difference between the % of value added in manufacturing in Guatemala and % of value added in manufacturing in Iran?
Make the answer very short. 6.45. In the year 1975, what is the difference between the % of value added in manufacturing of Guatemala and % of value added in manufacturing of Italy?
Your answer should be compact. 3.33. In the year 1975, what is the difference between the % of value added in manufacturing in Iran and % of value added in manufacturing in Italy?
Ensure brevity in your answer.  -3.12. In the year 1976, what is the difference between the % of value added in manufacturing in Algeria and % of value added in manufacturing in Guatemala?
Provide a short and direct response. -9.01. In the year 1976, what is the difference between the % of value added in manufacturing of Algeria and % of value added in manufacturing of Iran?
Provide a short and direct response. -3.1. In the year 1976, what is the difference between the % of value added in manufacturing of Algeria and % of value added in manufacturing of Italy?
Your answer should be compact. -6.73. In the year 1976, what is the difference between the % of value added in manufacturing of Guatemala and % of value added in manufacturing of Iran?
Offer a terse response. 5.91. In the year 1976, what is the difference between the % of value added in manufacturing of Guatemala and % of value added in manufacturing of Italy?
Provide a succinct answer. 2.28. In the year 1976, what is the difference between the % of value added in manufacturing of Iran and % of value added in manufacturing of Italy?
Provide a short and direct response. -3.63. In the year 1977, what is the difference between the % of value added in manufacturing in Algeria and % of value added in manufacturing in Guatemala?
Provide a short and direct response. -8.25. In the year 1977, what is the difference between the % of value added in manufacturing in Algeria and % of value added in manufacturing in Iran?
Your answer should be very brief. -3.59. In the year 1977, what is the difference between the % of value added in manufacturing in Algeria and % of value added in manufacturing in Italy?
Make the answer very short. -6.07. In the year 1977, what is the difference between the % of value added in manufacturing of Guatemala and % of value added in manufacturing of Iran?
Give a very brief answer. 4.66. In the year 1977, what is the difference between the % of value added in manufacturing of Guatemala and % of value added in manufacturing of Italy?
Offer a terse response. 2.18. In the year 1977, what is the difference between the % of value added in manufacturing of Iran and % of value added in manufacturing of Italy?
Your answer should be very brief. -2.48. In the year 1979, what is the difference between the % of value added in manufacturing in Algeria and % of value added in manufacturing in Guatemala?
Offer a terse response. -12.86. In the year 1979, what is the difference between the % of value added in manufacturing in Algeria and % of value added in manufacturing in Iran?
Your response must be concise. -1.28. In the year 1979, what is the difference between the % of value added in manufacturing in Algeria and % of value added in manufacturing in Italy?
Give a very brief answer. -8.25. In the year 1979, what is the difference between the % of value added in manufacturing in Guatemala and % of value added in manufacturing in Iran?
Your answer should be very brief. 11.57. In the year 1979, what is the difference between the % of value added in manufacturing in Guatemala and % of value added in manufacturing in Italy?
Your response must be concise. 4.61. In the year 1979, what is the difference between the % of value added in manufacturing in Iran and % of value added in manufacturing in Italy?
Provide a succinct answer. -6.97. In the year 1980, what is the difference between the % of value added in manufacturing of Algeria and % of value added in manufacturing of Guatemala?
Ensure brevity in your answer.  -14.45. In the year 1980, what is the difference between the % of value added in manufacturing in Algeria and % of value added in manufacturing in Iran?
Provide a short and direct response. -1.61. In the year 1980, what is the difference between the % of value added in manufacturing of Algeria and % of value added in manufacturing of Italy?
Keep it short and to the point. -7.82. In the year 1980, what is the difference between the % of value added in manufacturing in Guatemala and % of value added in manufacturing in Iran?
Your response must be concise. 12.84. In the year 1980, what is the difference between the % of value added in manufacturing in Guatemala and % of value added in manufacturing in Italy?
Provide a short and direct response. 6.63. In the year 1980, what is the difference between the % of value added in manufacturing of Iran and % of value added in manufacturing of Italy?
Give a very brief answer. -6.21. In the year 1981, what is the difference between the % of value added in manufacturing in Algeria and % of value added in manufacturing in Guatemala?
Provide a succinct answer. -13.22. In the year 1981, what is the difference between the % of value added in manufacturing of Algeria and % of value added in manufacturing of Iran?
Ensure brevity in your answer.  -2.21. In the year 1981, what is the difference between the % of value added in manufacturing of Algeria and % of value added in manufacturing of Italy?
Give a very brief answer. -7.77. In the year 1981, what is the difference between the % of value added in manufacturing in Guatemala and % of value added in manufacturing in Iran?
Provide a succinct answer. 11.01. In the year 1981, what is the difference between the % of value added in manufacturing in Guatemala and % of value added in manufacturing in Italy?
Give a very brief answer. 5.44. In the year 1981, what is the difference between the % of value added in manufacturing of Iran and % of value added in manufacturing of Italy?
Your answer should be very brief. -5.56. In the year 1982, what is the difference between the % of value added in manufacturing in Algeria and % of value added in manufacturing in Guatemala?
Keep it short and to the point. -14.53. In the year 1982, what is the difference between the % of value added in manufacturing in Algeria and % of value added in manufacturing in Iran?
Provide a short and direct response. -3.13. In the year 1982, what is the difference between the % of value added in manufacturing in Algeria and % of value added in manufacturing in Italy?
Your answer should be compact. -8.04. In the year 1982, what is the difference between the % of value added in manufacturing in Guatemala and % of value added in manufacturing in Iran?
Your answer should be very brief. 11.4. In the year 1982, what is the difference between the % of value added in manufacturing in Guatemala and % of value added in manufacturing in Italy?
Your answer should be very brief. 6.5. In the year 1982, what is the difference between the % of value added in manufacturing of Iran and % of value added in manufacturing of Italy?
Ensure brevity in your answer.  -4.9. In the year 1983, what is the difference between the % of value added in manufacturing in Algeria and % of value added in manufacturing in Guatemala?
Give a very brief answer. -13.16. In the year 1983, what is the difference between the % of value added in manufacturing in Algeria and % of value added in manufacturing in Iran?
Offer a very short reply. -3.93. In the year 1983, what is the difference between the % of value added in manufacturing of Algeria and % of value added in manufacturing of Italy?
Your answer should be very brief. -6.45. In the year 1983, what is the difference between the % of value added in manufacturing in Guatemala and % of value added in manufacturing in Iran?
Ensure brevity in your answer.  9.23. In the year 1983, what is the difference between the % of value added in manufacturing in Guatemala and % of value added in manufacturing in Italy?
Offer a very short reply. 6.71. In the year 1983, what is the difference between the % of value added in manufacturing of Iran and % of value added in manufacturing of Italy?
Your answer should be compact. -2.52. What is the ratio of the % of value added in manufacturing in Algeria in 1975 to that in 1976?
Offer a very short reply. 1. What is the ratio of the % of value added in manufacturing of Guatemala in 1975 to that in 1976?
Make the answer very short. 1.07. What is the ratio of the % of value added in manufacturing in Iran in 1975 to that in 1976?
Your answer should be compact. 1.05. What is the ratio of the % of value added in manufacturing of Algeria in 1975 to that in 1977?
Provide a succinct answer. 1.06. What is the ratio of the % of value added in manufacturing in Guatemala in 1975 to that in 1977?
Your response must be concise. 1.15. What is the ratio of the % of value added in manufacturing in Iran in 1975 to that in 1977?
Provide a succinct answer. 1.03. What is the ratio of the % of value added in manufacturing in Italy in 1975 to that in 1977?
Your response must be concise. 1.08. What is the ratio of the % of value added in manufacturing in Algeria in 1975 to that in 1979?
Your response must be concise. 1.73. What is the ratio of the % of value added in manufacturing of Guatemala in 1975 to that in 1979?
Make the answer very short. 0.96. What is the ratio of the % of value added in manufacturing in Iran in 1975 to that in 1979?
Offer a very short reply. 2.03. What is the ratio of the % of value added in manufacturing in Italy in 1975 to that in 1979?
Keep it short and to the point. 1.06. What is the ratio of the % of value added in manufacturing of Algeria in 1975 to that in 1980?
Offer a very short reply. 1.84. What is the ratio of the % of value added in manufacturing in Guatemala in 1975 to that in 1980?
Your answer should be very brief. 0.89. What is the ratio of the % of value added in manufacturing in Iran in 1975 to that in 1980?
Make the answer very short. 1.97. What is the ratio of the % of value added in manufacturing in Italy in 1975 to that in 1980?
Make the answer very short. 1.12. What is the ratio of the % of value added in manufacturing of Algeria in 1975 to that in 1981?
Offer a terse response. 1.9. What is the ratio of the % of value added in manufacturing in Guatemala in 1975 to that in 1981?
Offer a very short reply. 0.96. What is the ratio of the % of value added in manufacturing in Iran in 1975 to that in 1981?
Offer a very short reply. 1.77. What is the ratio of the % of value added in manufacturing of Italy in 1975 to that in 1981?
Make the answer very short. 1.14. What is the ratio of the % of value added in manufacturing of Algeria in 1975 to that in 1982?
Provide a succinct answer. 1.94. What is the ratio of the % of value added in manufacturing of Guatemala in 1975 to that in 1982?
Your answer should be very brief. 0.89. What is the ratio of the % of value added in manufacturing of Iran in 1975 to that in 1982?
Give a very brief answer. 1.51. What is the ratio of the % of value added in manufacturing of Italy in 1975 to that in 1982?
Ensure brevity in your answer.  1.11. What is the ratio of the % of value added in manufacturing in Algeria in 1975 to that in 1983?
Offer a very short reply. 1.99. What is the ratio of the % of value added in manufacturing of Guatemala in 1975 to that in 1983?
Offer a very short reply. 0.97. What is the ratio of the % of value added in manufacturing in Iran in 1975 to that in 1983?
Ensure brevity in your answer.  1.35. What is the ratio of the % of value added in manufacturing in Italy in 1975 to that in 1983?
Offer a very short reply. 1.31. What is the ratio of the % of value added in manufacturing in Algeria in 1976 to that in 1977?
Ensure brevity in your answer.  1.06. What is the ratio of the % of value added in manufacturing of Guatemala in 1976 to that in 1977?
Keep it short and to the point. 1.08. What is the ratio of the % of value added in manufacturing of Iran in 1976 to that in 1977?
Your response must be concise. 0.98. What is the ratio of the % of value added in manufacturing of Italy in 1976 to that in 1977?
Ensure brevity in your answer.  1.09. What is the ratio of the % of value added in manufacturing in Algeria in 1976 to that in 1979?
Provide a succinct answer. 1.73. What is the ratio of the % of value added in manufacturing in Guatemala in 1976 to that in 1979?
Your answer should be compact. 0.9. What is the ratio of the % of value added in manufacturing of Iran in 1976 to that in 1979?
Your answer should be compact. 1.93. What is the ratio of the % of value added in manufacturing in Italy in 1976 to that in 1979?
Keep it short and to the point. 1.07. What is the ratio of the % of value added in manufacturing in Algeria in 1976 to that in 1980?
Give a very brief answer. 1.85. What is the ratio of the % of value added in manufacturing of Guatemala in 1976 to that in 1980?
Your answer should be compact. 0.83. What is the ratio of the % of value added in manufacturing in Iran in 1976 to that in 1980?
Offer a very short reply. 1.88. What is the ratio of the % of value added in manufacturing in Italy in 1976 to that in 1980?
Your response must be concise. 1.13. What is the ratio of the % of value added in manufacturing in Algeria in 1976 to that in 1981?
Give a very brief answer. 1.9. What is the ratio of the % of value added in manufacturing in Guatemala in 1976 to that in 1981?
Offer a terse response. 0.9. What is the ratio of the % of value added in manufacturing in Iran in 1976 to that in 1981?
Offer a very short reply. 1.68. What is the ratio of the % of value added in manufacturing of Italy in 1976 to that in 1981?
Provide a succinct answer. 1.14. What is the ratio of the % of value added in manufacturing of Algeria in 1976 to that in 1982?
Make the answer very short. 1.94. What is the ratio of the % of value added in manufacturing of Guatemala in 1976 to that in 1982?
Give a very brief answer. 0.83. What is the ratio of the % of value added in manufacturing in Iran in 1976 to that in 1982?
Offer a very short reply. 1.44. What is the ratio of the % of value added in manufacturing in Italy in 1976 to that in 1982?
Your answer should be compact. 1.12. What is the ratio of the % of value added in manufacturing in Algeria in 1976 to that in 1983?
Provide a short and direct response. 1.99. What is the ratio of the % of value added in manufacturing in Guatemala in 1976 to that in 1983?
Offer a terse response. 0.91. What is the ratio of the % of value added in manufacturing of Iran in 1976 to that in 1983?
Ensure brevity in your answer.  1.28. What is the ratio of the % of value added in manufacturing in Italy in 1976 to that in 1983?
Provide a succinct answer. 1.32. What is the ratio of the % of value added in manufacturing in Algeria in 1977 to that in 1979?
Provide a succinct answer. 1.64. What is the ratio of the % of value added in manufacturing of Guatemala in 1977 to that in 1979?
Your answer should be compact. 0.84. What is the ratio of the % of value added in manufacturing of Iran in 1977 to that in 1979?
Provide a succinct answer. 1.98. What is the ratio of the % of value added in manufacturing of Italy in 1977 to that in 1979?
Give a very brief answer. 0.98. What is the ratio of the % of value added in manufacturing of Algeria in 1977 to that in 1980?
Your answer should be very brief. 1.74. What is the ratio of the % of value added in manufacturing in Guatemala in 1977 to that in 1980?
Give a very brief answer. 0.77. What is the ratio of the % of value added in manufacturing in Iran in 1977 to that in 1980?
Provide a short and direct response. 1.92. What is the ratio of the % of value added in manufacturing in Italy in 1977 to that in 1980?
Ensure brevity in your answer.  1.04. What is the ratio of the % of value added in manufacturing in Algeria in 1977 to that in 1981?
Give a very brief answer. 1.8. What is the ratio of the % of value added in manufacturing in Guatemala in 1977 to that in 1981?
Provide a short and direct response. 0.83. What is the ratio of the % of value added in manufacturing of Iran in 1977 to that in 1981?
Offer a very short reply. 1.72. What is the ratio of the % of value added in manufacturing in Italy in 1977 to that in 1981?
Give a very brief answer. 1.05. What is the ratio of the % of value added in manufacturing in Algeria in 1977 to that in 1982?
Offer a very short reply. 1.84. What is the ratio of the % of value added in manufacturing in Guatemala in 1977 to that in 1982?
Ensure brevity in your answer.  0.77. What is the ratio of the % of value added in manufacturing in Iran in 1977 to that in 1982?
Your answer should be very brief. 1.47. What is the ratio of the % of value added in manufacturing in Italy in 1977 to that in 1982?
Provide a succinct answer. 1.03. What is the ratio of the % of value added in manufacturing in Algeria in 1977 to that in 1983?
Make the answer very short. 1.88. What is the ratio of the % of value added in manufacturing in Guatemala in 1977 to that in 1983?
Provide a succinct answer. 0.84. What is the ratio of the % of value added in manufacturing in Iran in 1977 to that in 1983?
Ensure brevity in your answer.  1.31. What is the ratio of the % of value added in manufacturing of Italy in 1977 to that in 1983?
Keep it short and to the point. 1.22. What is the ratio of the % of value added in manufacturing of Algeria in 1979 to that in 1980?
Your answer should be compact. 1.07. What is the ratio of the % of value added in manufacturing of Guatemala in 1979 to that in 1980?
Your response must be concise. 0.92. What is the ratio of the % of value added in manufacturing of Iran in 1979 to that in 1980?
Offer a terse response. 0.97. What is the ratio of the % of value added in manufacturing of Italy in 1979 to that in 1980?
Provide a short and direct response. 1.06. What is the ratio of the % of value added in manufacturing in Algeria in 1979 to that in 1981?
Provide a short and direct response. 1.1. What is the ratio of the % of value added in manufacturing in Iran in 1979 to that in 1981?
Your response must be concise. 0.87. What is the ratio of the % of value added in manufacturing of Italy in 1979 to that in 1981?
Offer a very short reply. 1.07. What is the ratio of the % of value added in manufacturing of Algeria in 1979 to that in 1982?
Keep it short and to the point. 1.12. What is the ratio of the % of value added in manufacturing in Guatemala in 1979 to that in 1982?
Your answer should be very brief. 0.92. What is the ratio of the % of value added in manufacturing of Iran in 1979 to that in 1982?
Provide a succinct answer. 0.74. What is the ratio of the % of value added in manufacturing in Italy in 1979 to that in 1982?
Make the answer very short. 1.05. What is the ratio of the % of value added in manufacturing of Algeria in 1979 to that in 1983?
Your answer should be very brief. 1.15. What is the ratio of the % of value added in manufacturing in Guatemala in 1979 to that in 1983?
Your response must be concise. 1.01. What is the ratio of the % of value added in manufacturing in Iran in 1979 to that in 1983?
Ensure brevity in your answer.  0.66. What is the ratio of the % of value added in manufacturing in Italy in 1979 to that in 1983?
Your answer should be compact. 1.24. What is the ratio of the % of value added in manufacturing of Algeria in 1980 to that in 1981?
Your response must be concise. 1.03. What is the ratio of the % of value added in manufacturing of Guatemala in 1980 to that in 1981?
Provide a short and direct response. 1.08. What is the ratio of the % of value added in manufacturing in Iran in 1980 to that in 1981?
Keep it short and to the point. 0.9. What is the ratio of the % of value added in manufacturing in Algeria in 1980 to that in 1982?
Your answer should be very brief. 1.05. What is the ratio of the % of value added in manufacturing of Guatemala in 1980 to that in 1982?
Your answer should be compact. 1. What is the ratio of the % of value added in manufacturing in Iran in 1980 to that in 1982?
Your answer should be very brief. 0.77. What is the ratio of the % of value added in manufacturing of Algeria in 1980 to that in 1983?
Your answer should be very brief. 1.08. What is the ratio of the % of value added in manufacturing of Guatemala in 1980 to that in 1983?
Offer a very short reply. 1.09. What is the ratio of the % of value added in manufacturing of Iran in 1980 to that in 1983?
Provide a short and direct response. 0.68. What is the ratio of the % of value added in manufacturing of Italy in 1980 to that in 1983?
Your answer should be very brief. 1.17. What is the ratio of the % of value added in manufacturing in Algeria in 1981 to that in 1982?
Keep it short and to the point. 1.02. What is the ratio of the % of value added in manufacturing of Guatemala in 1981 to that in 1982?
Make the answer very short. 0.93. What is the ratio of the % of value added in manufacturing of Iran in 1981 to that in 1982?
Ensure brevity in your answer.  0.85. What is the ratio of the % of value added in manufacturing in Italy in 1981 to that in 1982?
Ensure brevity in your answer.  0.98. What is the ratio of the % of value added in manufacturing in Algeria in 1981 to that in 1983?
Provide a short and direct response. 1.05. What is the ratio of the % of value added in manufacturing in Guatemala in 1981 to that in 1983?
Provide a succinct answer. 1.01. What is the ratio of the % of value added in manufacturing of Iran in 1981 to that in 1983?
Provide a succinct answer. 0.76. What is the ratio of the % of value added in manufacturing in Italy in 1981 to that in 1983?
Make the answer very short. 1.16. What is the ratio of the % of value added in manufacturing of Algeria in 1982 to that in 1983?
Give a very brief answer. 1.02. What is the ratio of the % of value added in manufacturing of Guatemala in 1982 to that in 1983?
Ensure brevity in your answer.  1.09. What is the ratio of the % of value added in manufacturing in Iran in 1982 to that in 1983?
Make the answer very short. 0.89. What is the ratio of the % of value added in manufacturing of Italy in 1982 to that in 1983?
Provide a short and direct response. 1.18. What is the difference between the highest and the second highest % of value added in manufacturing in Algeria?
Your answer should be very brief. 0.01. What is the difference between the highest and the second highest % of value added in manufacturing of Guatemala?
Your response must be concise. 0.06. What is the difference between the highest and the second highest % of value added in manufacturing of Iran?
Provide a succinct answer. 0.24. What is the difference between the highest and the second highest % of value added in manufacturing in Italy?
Offer a terse response. 0.08. What is the difference between the highest and the lowest % of value added in manufacturing in Algeria?
Offer a terse response. 2.69. What is the difference between the highest and the lowest % of value added in manufacturing of Guatemala?
Offer a very short reply. 4.02. What is the difference between the highest and the lowest % of value added in manufacturing of Iran?
Your answer should be very brief. 4.53. What is the difference between the highest and the lowest % of value added in manufacturing of Italy?
Provide a short and direct response. 2.97. 